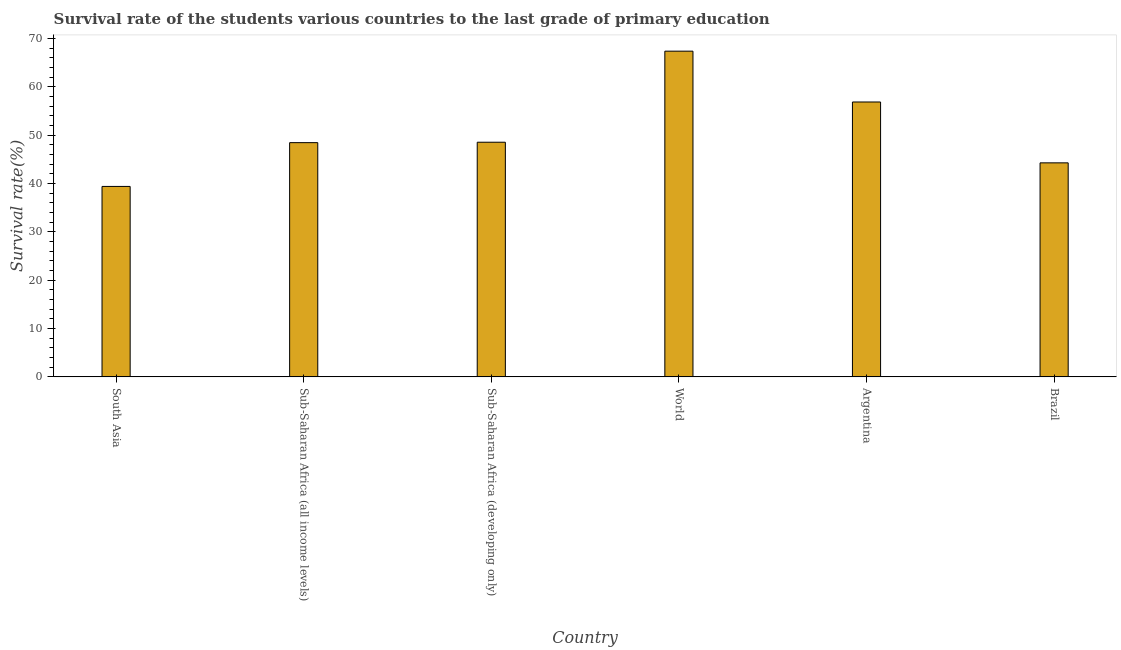Does the graph contain grids?
Provide a short and direct response. No. What is the title of the graph?
Keep it short and to the point. Survival rate of the students various countries to the last grade of primary education. What is the label or title of the Y-axis?
Offer a very short reply. Survival rate(%). What is the survival rate in primary education in Argentina?
Provide a short and direct response. 56.87. Across all countries, what is the maximum survival rate in primary education?
Your answer should be compact. 67.38. Across all countries, what is the minimum survival rate in primary education?
Offer a very short reply. 39.4. In which country was the survival rate in primary education minimum?
Offer a terse response. South Asia. What is the sum of the survival rate in primary education?
Your response must be concise. 304.92. What is the difference between the survival rate in primary education in Argentina and Sub-Saharan Africa (developing only)?
Provide a succinct answer. 8.32. What is the average survival rate in primary education per country?
Provide a succinct answer. 50.82. What is the median survival rate in primary education?
Ensure brevity in your answer.  48.5. In how many countries, is the survival rate in primary education greater than 10 %?
Make the answer very short. 6. What is the ratio of the survival rate in primary education in Argentina to that in South Asia?
Ensure brevity in your answer.  1.44. Is the difference between the survival rate in primary education in Sub-Saharan Africa (developing only) and World greater than the difference between any two countries?
Provide a short and direct response. No. What is the difference between the highest and the second highest survival rate in primary education?
Ensure brevity in your answer.  10.51. Is the sum of the survival rate in primary education in Sub-Saharan Africa (all income levels) and World greater than the maximum survival rate in primary education across all countries?
Your answer should be compact. Yes. What is the difference between the highest and the lowest survival rate in primary education?
Make the answer very short. 27.98. Are all the bars in the graph horizontal?
Give a very brief answer. No. What is the difference between two consecutive major ticks on the Y-axis?
Make the answer very short. 10. Are the values on the major ticks of Y-axis written in scientific E-notation?
Provide a succinct answer. No. What is the Survival rate(%) of South Asia?
Your response must be concise. 39.4. What is the Survival rate(%) of Sub-Saharan Africa (all income levels)?
Your answer should be very brief. 48.46. What is the Survival rate(%) in Sub-Saharan Africa (developing only)?
Your response must be concise. 48.54. What is the Survival rate(%) in World?
Provide a short and direct response. 67.38. What is the Survival rate(%) in Argentina?
Offer a very short reply. 56.87. What is the Survival rate(%) of Brazil?
Provide a succinct answer. 44.27. What is the difference between the Survival rate(%) in South Asia and Sub-Saharan Africa (all income levels)?
Your answer should be very brief. -9.06. What is the difference between the Survival rate(%) in South Asia and Sub-Saharan Africa (developing only)?
Make the answer very short. -9.15. What is the difference between the Survival rate(%) in South Asia and World?
Your answer should be compact. -27.98. What is the difference between the Survival rate(%) in South Asia and Argentina?
Provide a succinct answer. -17.47. What is the difference between the Survival rate(%) in South Asia and Brazil?
Make the answer very short. -4.88. What is the difference between the Survival rate(%) in Sub-Saharan Africa (all income levels) and Sub-Saharan Africa (developing only)?
Give a very brief answer. -0.09. What is the difference between the Survival rate(%) in Sub-Saharan Africa (all income levels) and World?
Provide a short and direct response. -18.93. What is the difference between the Survival rate(%) in Sub-Saharan Africa (all income levels) and Argentina?
Give a very brief answer. -8.41. What is the difference between the Survival rate(%) in Sub-Saharan Africa (all income levels) and Brazil?
Ensure brevity in your answer.  4.18. What is the difference between the Survival rate(%) in Sub-Saharan Africa (developing only) and World?
Your answer should be compact. -18.84. What is the difference between the Survival rate(%) in Sub-Saharan Africa (developing only) and Argentina?
Your answer should be compact. -8.32. What is the difference between the Survival rate(%) in Sub-Saharan Africa (developing only) and Brazil?
Your response must be concise. 4.27. What is the difference between the Survival rate(%) in World and Argentina?
Make the answer very short. 10.51. What is the difference between the Survival rate(%) in World and Brazil?
Offer a terse response. 23.11. What is the difference between the Survival rate(%) in Argentina and Brazil?
Give a very brief answer. 12.59. What is the ratio of the Survival rate(%) in South Asia to that in Sub-Saharan Africa (all income levels)?
Keep it short and to the point. 0.81. What is the ratio of the Survival rate(%) in South Asia to that in Sub-Saharan Africa (developing only)?
Your response must be concise. 0.81. What is the ratio of the Survival rate(%) in South Asia to that in World?
Your response must be concise. 0.58. What is the ratio of the Survival rate(%) in South Asia to that in Argentina?
Your answer should be compact. 0.69. What is the ratio of the Survival rate(%) in South Asia to that in Brazil?
Your answer should be compact. 0.89. What is the ratio of the Survival rate(%) in Sub-Saharan Africa (all income levels) to that in World?
Your response must be concise. 0.72. What is the ratio of the Survival rate(%) in Sub-Saharan Africa (all income levels) to that in Argentina?
Provide a succinct answer. 0.85. What is the ratio of the Survival rate(%) in Sub-Saharan Africa (all income levels) to that in Brazil?
Provide a succinct answer. 1.09. What is the ratio of the Survival rate(%) in Sub-Saharan Africa (developing only) to that in World?
Your answer should be very brief. 0.72. What is the ratio of the Survival rate(%) in Sub-Saharan Africa (developing only) to that in Argentina?
Provide a short and direct response. 0.85. What is the ratio of the Survival rate(%) in Sub-Saharan Africa (developing only) to that in Brazil?
Provide a succinct answer. 1.1. What is the ratio of the Survival rate(%) in World to that in Argentina?
Offer a very short reply. 1.19. What is the ratio of the Survival rate(%) in World to that in Brazil?
Keep it short and to the point. 1.52. What is the ratio of the Survival rate(%) in Argentina to that in Brazil?
Provide a short and direct response. 1.28. 